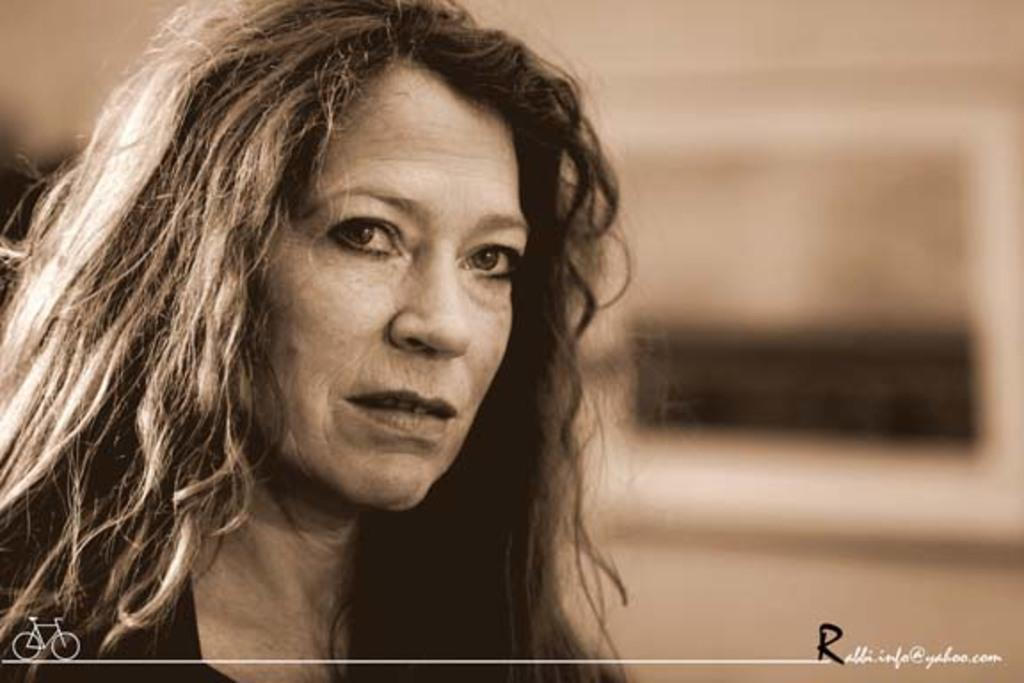Who is present in the image? There is a woman in the image. What object can be seen alongside the woman? There is a bicycle in the image. In what direction is the woman riding the bicycle in the image? The image does not show the woman riding the bicycle, so it is not possible to determine the direction. 